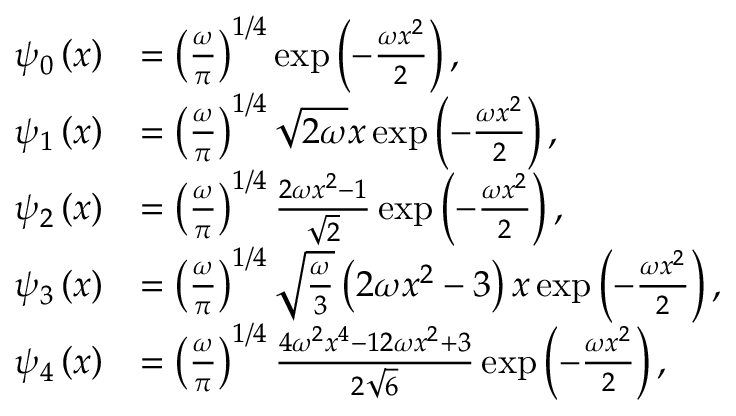<formula> <loc_0><loc_0><loc_500><loc_500>\begin{array} { r l } { \psi _ { 0 } \left ( x \right ) } & { = \left ( \frac { \omega } { \pi } \right ) ^ { 1 / 4 } \exp \left ( - \frac { \omega x ^ { 2 } } { 2 } \right ) , } \\ { \psi _ { 1 } \left ( x \right ) } & { = \left ( \frac { \omega } { \pi } \right ) ^ { 1 / 4 } \sqrt { 2 \omega } x \exp \left ( - \frac { \omega x ^ { 2 } } { 2 } \right ) , } \\ { \psi _ { 2 } \left ( x \right ) } & { = \left ( \frac { \omega } { \pi } \right ) ^ { 1 / 4 } \frac { 2 \omega x ^ { 2 } - 1 } { \sqrt { 2 } } \exp \left ( - \frac { \omega x ^ { 2 } } { 2 } \right ) , } \\ { \psi _ { 3 } \left ( x \right ) } & { = \left ( \frac { \omega } { \pi } \right ) ^ { 1 / 4 } \sqrt { \frac { \omega } { 3 } } \left ( 2 \omega x ^ { 2 } - 3 \right ) x \exp \left ( - \frac { \omega x ^ { 2 } } { 2 } \right ) , } \\ { \psi _ { 4 } \left ( x \right ) } & { = \left ( \frac { \omega } { \pi } \right ) ^ { 1 / 4 } \frac { 4 \omega ^ { 2 } x ^ { 4 } - 1 2 \omega x ^ { 2 } + 3 } { 2 \sqrt { 6 } } \exp \left ( - \frac { \omega x ^ { 2 } } { 2 } \right ) , } \end{array}</formula> 